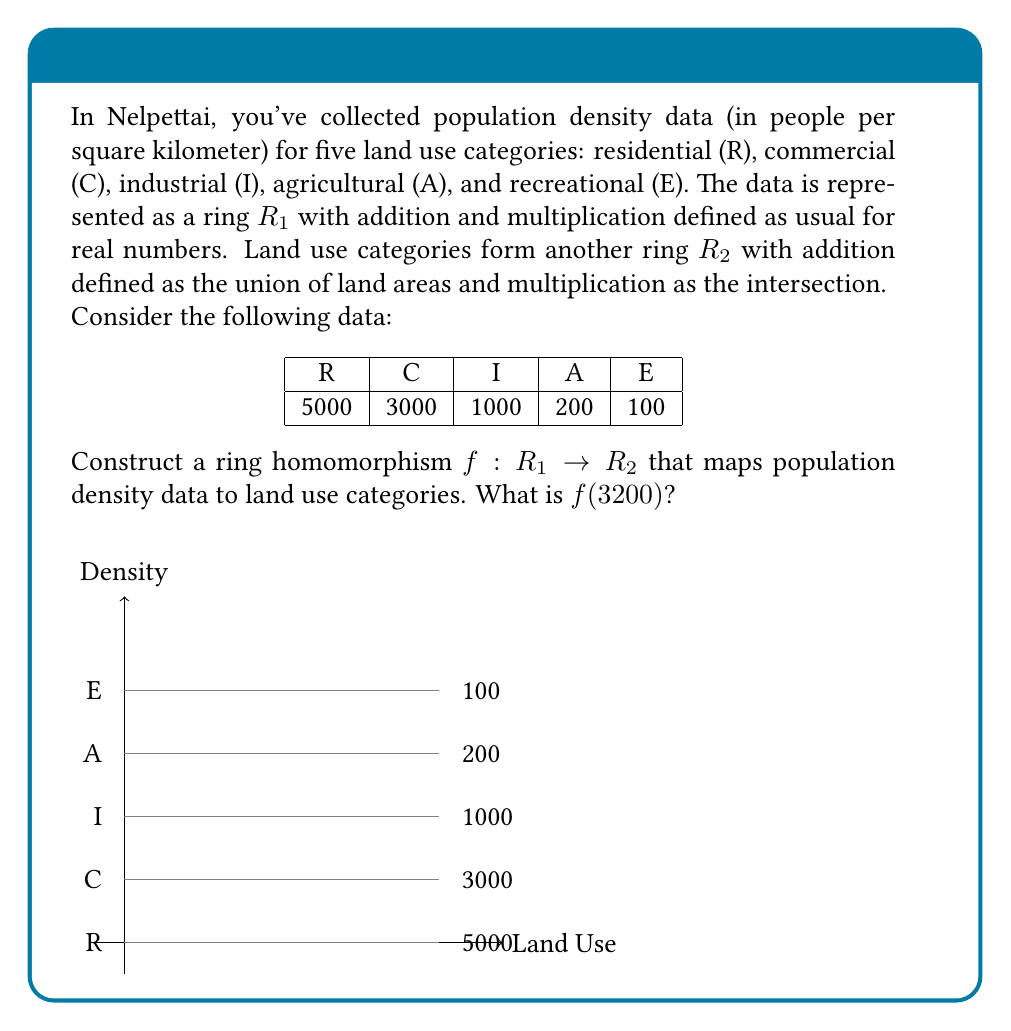Help me with this question. To construct a ring homomorphism $f: R_1 \rightarrow R_2$, we need to define a function that preserves both addition and multiplication operations between the rings. Let's approach this step-by-step:

1) First, we need to define how $f$ maps elements from $R_1$ to $R_2$. We can do this by creating thresholds based on the given density data:

   $f(x) = \begin{cases} 
   E & \text{if } 0 \leq x < 150 \\
   A & \text{if } 150 \leq x < 600 \\
   I & \text{if } 600 \leq x < 2000 \\
   C & \text{if } 2000 \leq x < 4000 \\
   R & \text{if } x \geq 4000
   \end{cases}$

2) Now, we need to verify that this function preserves addition and multiplication:

   For addition: $f(x + y) = f(x) \cup f(y)$
   For multiplication: $f(x \cdot y) = f(x) \cap f(y)$

3) Let's check $f(3200)$:
   
   3200 falls in the range $2000 \leq x < 4000$, so $f(3200) = C$

4) To verify this is indeed a ring homomorphism, we can check a few examples:

   $f(5000 + 3000) = f(8000) = R$
   $f(5000) \cup f(3000) = R \cup C = R$

   $f(5000 \cdot 3000) = f(15000000) = R$
   $f(5000) \cap f(3000) = R \cap C = C$

   While this doesn't prove it's a homomorphism for all cases, it demonstrates the principle.
Answer: $C$ 